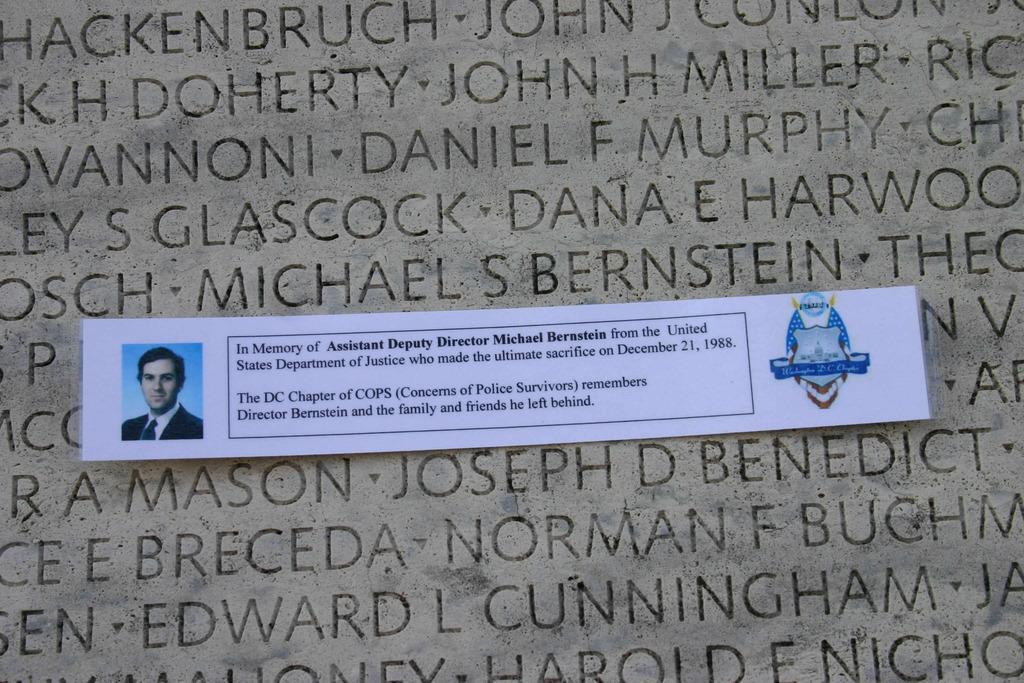How would you summarize this image in a sentence or two? In this picture we can see a paper, in the paper we can find a man. 